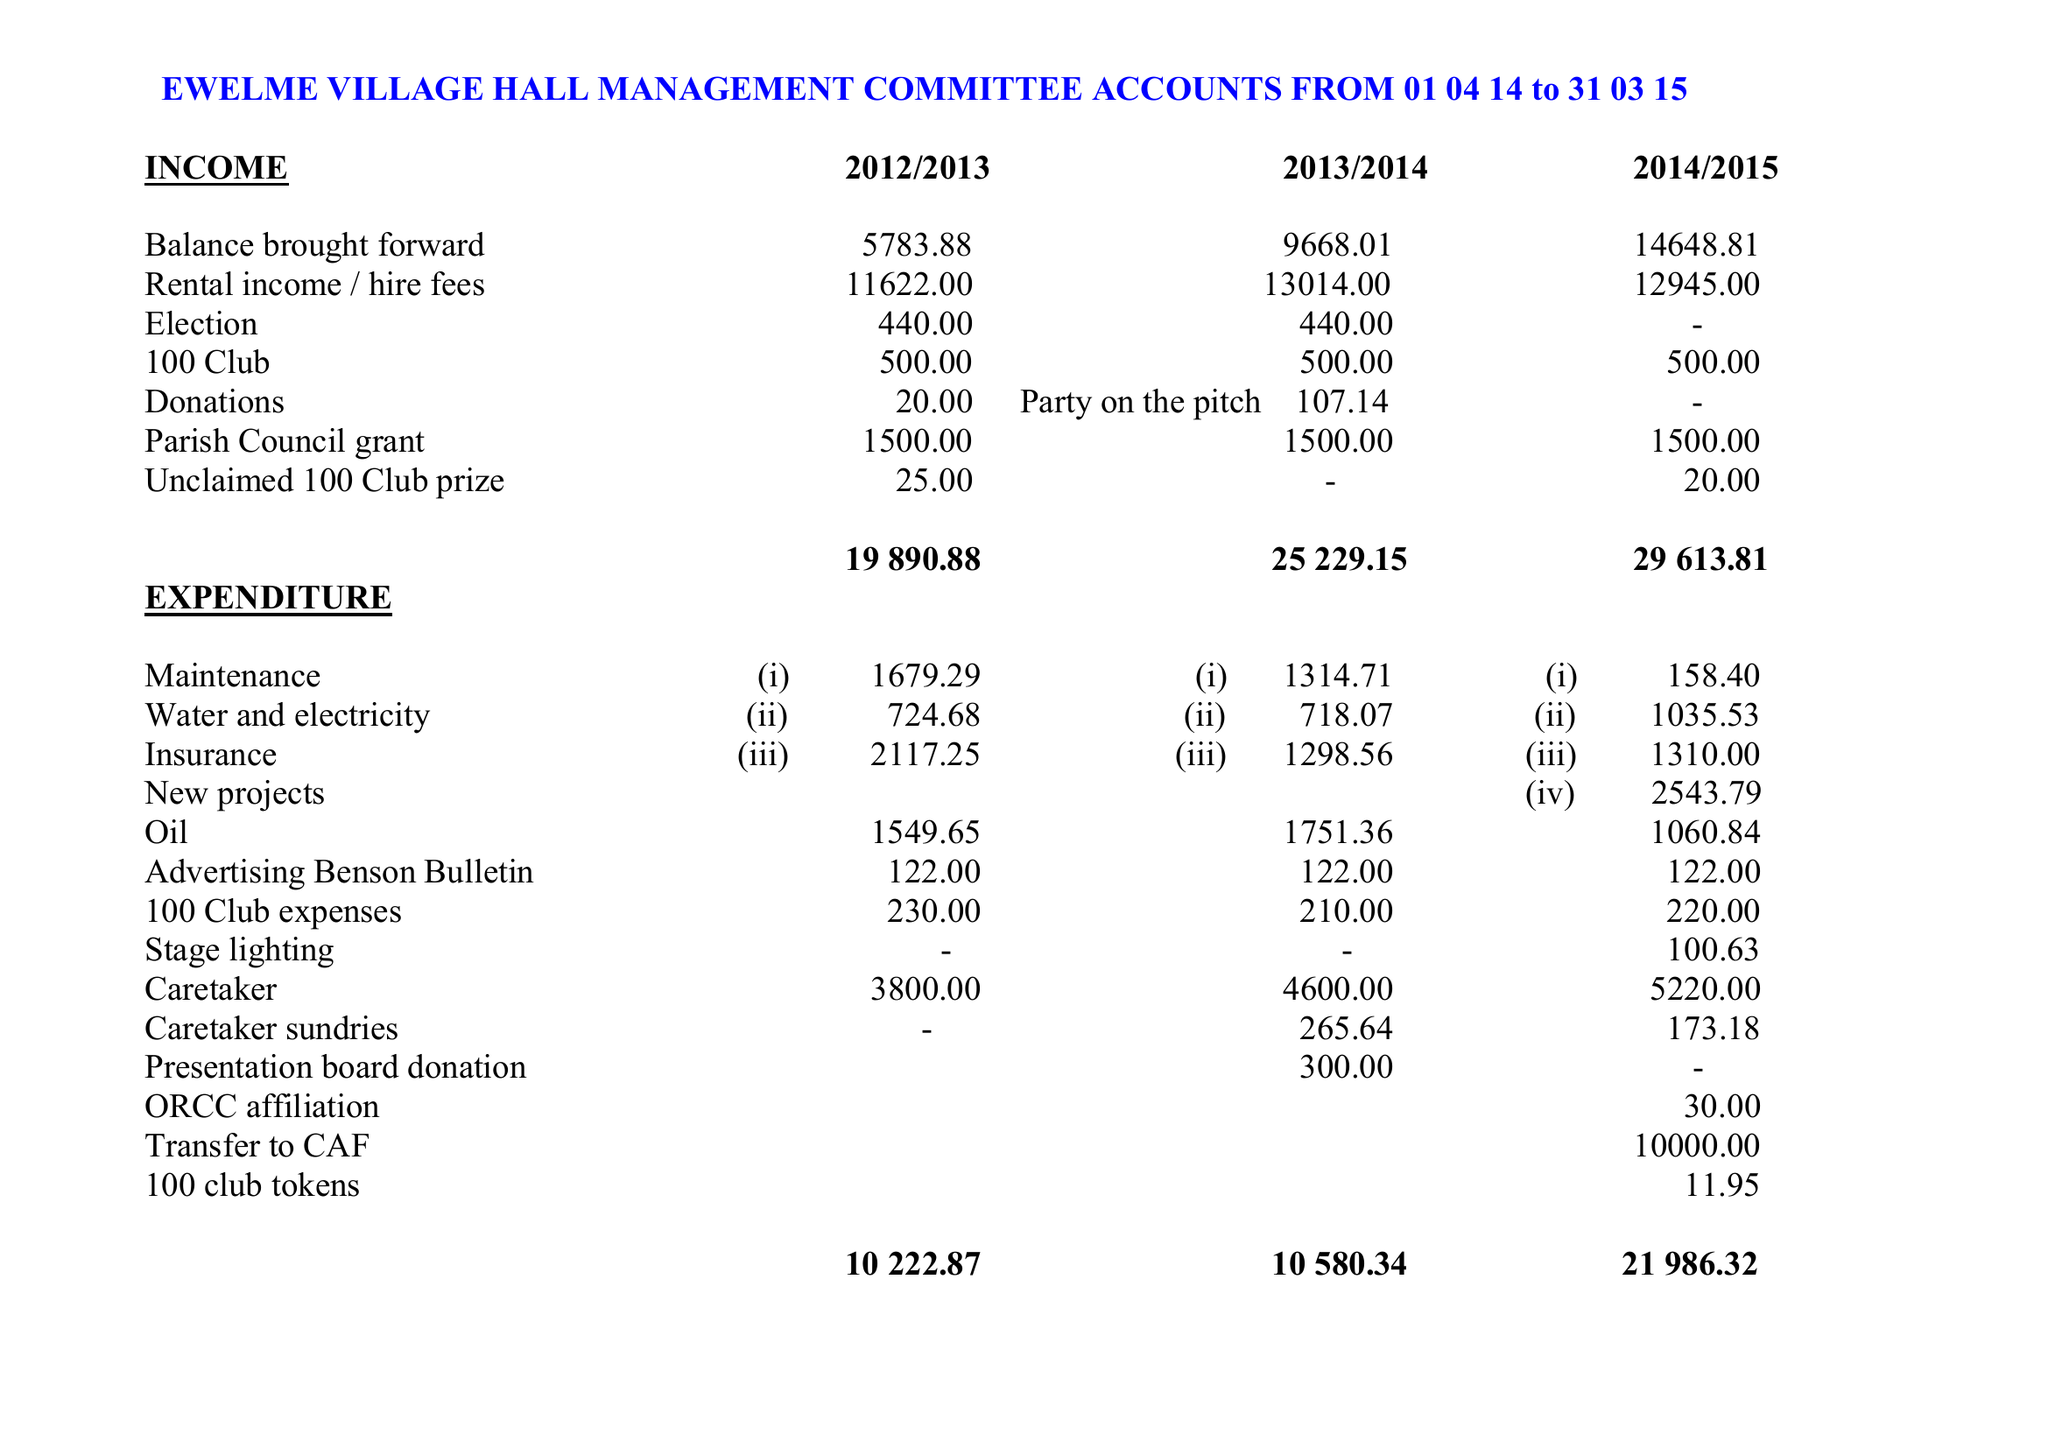What is the value for the charity_name?
Answer the question using a single word or phrase. Ewelme Village Hall 